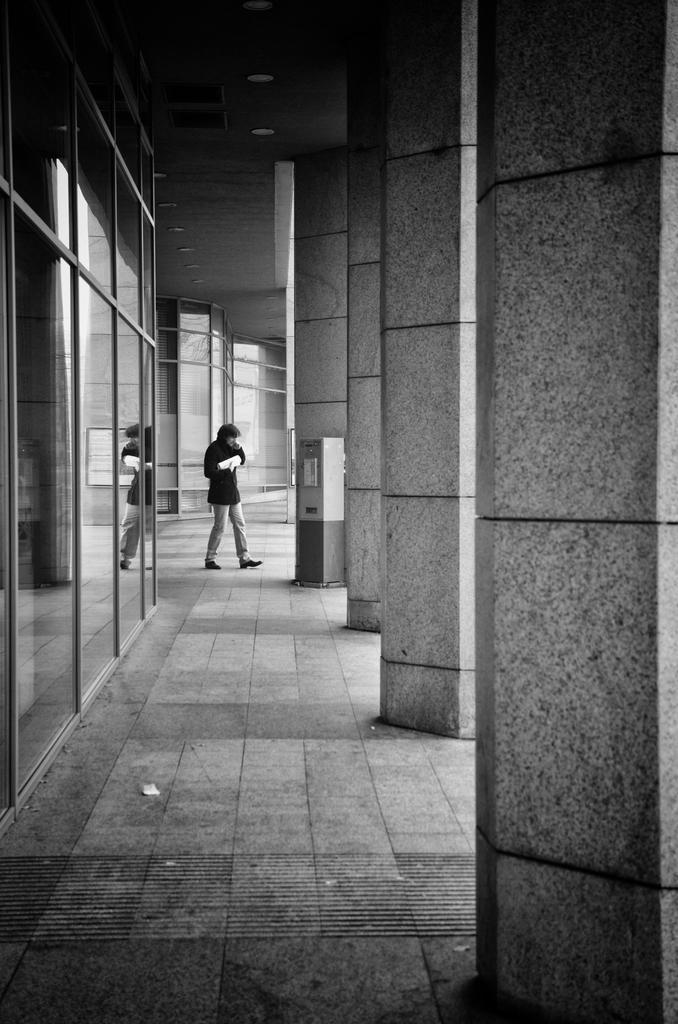Please provide a concise description of this image. In the center of the image we can see a person and there are pillars. On the left there are glass doors. 